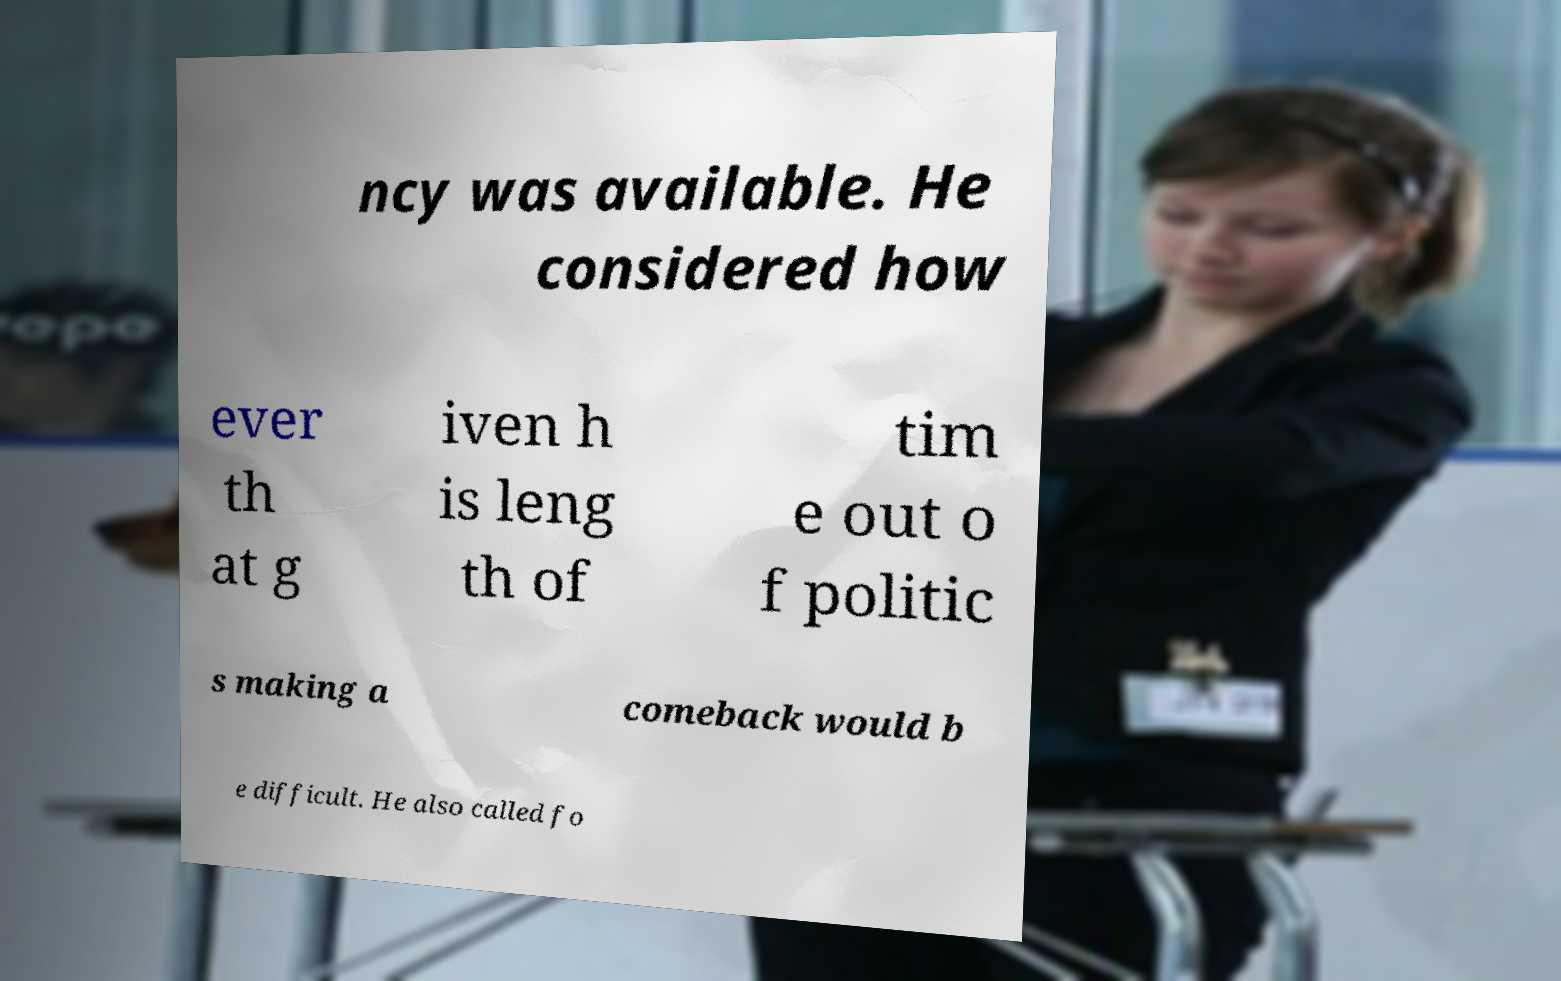Please read and relay the text visible in this image. What does it say? ncy was available. He considered how ever th at g iven h is leng th of tim e out o f politic s making a comeback would b e difficult. He also called fo 